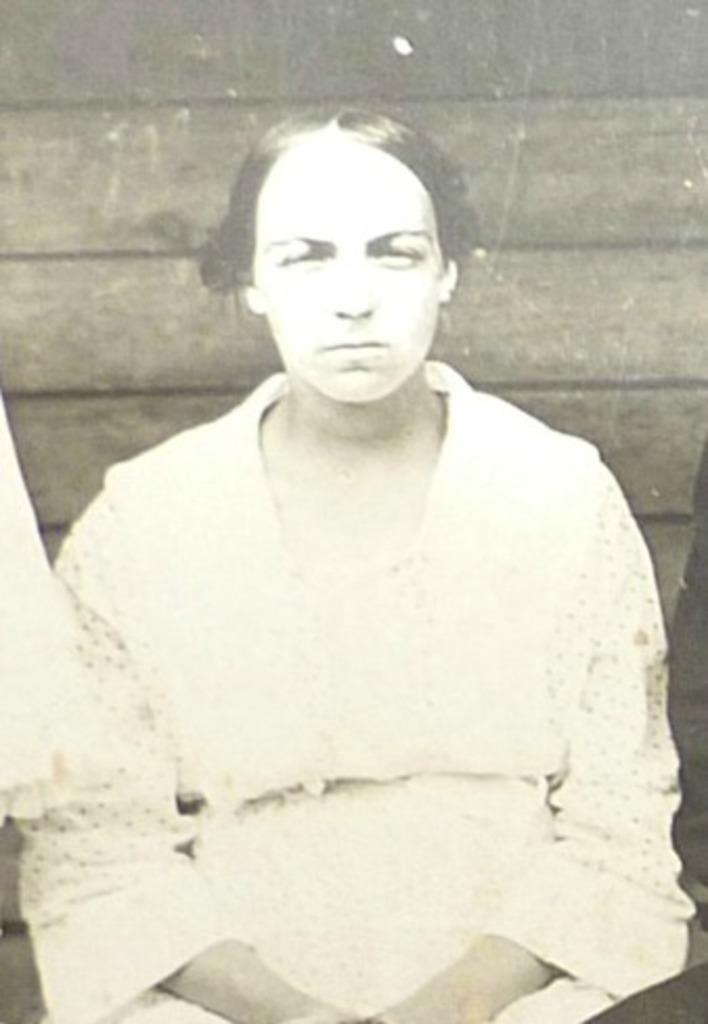What is the main subject of the image? There is a person in the image. What color scheme is used in the image? The image is in black and white. Can you see the whip being used by the person in the image? There is no whip present in the image. What type of desk can be seen in the image? There is no desk present in the image. Is the person standing near the ocean in the image? There is no ocean present in the image. 